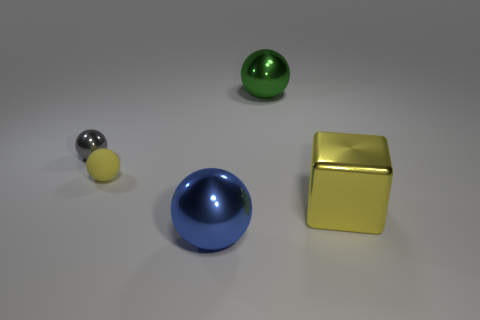Can you describe the arrangement and colors of the objects in the image? Certainly! In the image, we have four distinct objects laid out on a flat surface. From left to right, there's a small shiny sphere with a silver and black pattern, a larger matte yellow sphere, a mid-sized glossy blue hemisphere, and to the far right, a matte yellow cube. 